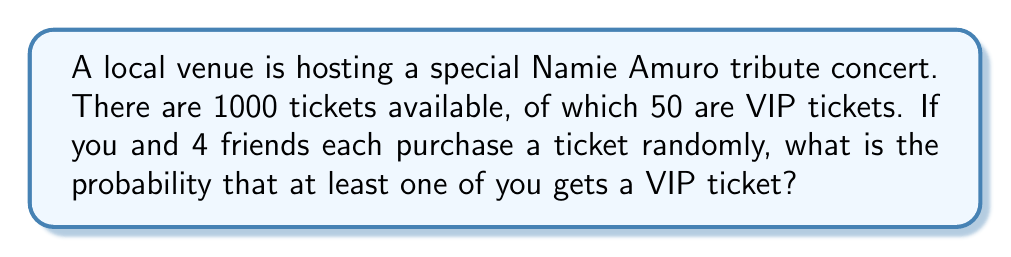What is the answer to this math problem? Let's approach this step-by-step:

1) First, let's calculate the probability of NOT getting a VIP ticket:
   $$P(\text{not VIP}) = \frac{950}{1000} = 0.95$$

2) For all 5 people to not get a VIP ticket, this needs to happen 5 times independently:
   $$P(\text{no one gets VIP}) = (0.95)^5 = 0.7738$$

3) Therefore, the probability of at least one person getting a VIP ticket is the complement of this:
   $$P(\text{at least one VIP}) = 1 - P(\text{no one gets VIP})$$
   $$= 1 - 0.7738 = 0.2262$$

4) To express this as a percentage:
   $$0.2262 \times 100\% = 22.62\%$$

Thus, there is a 22.62% chance that at least one person in your group will get a VIP ticket.
Answer: 22.62% 